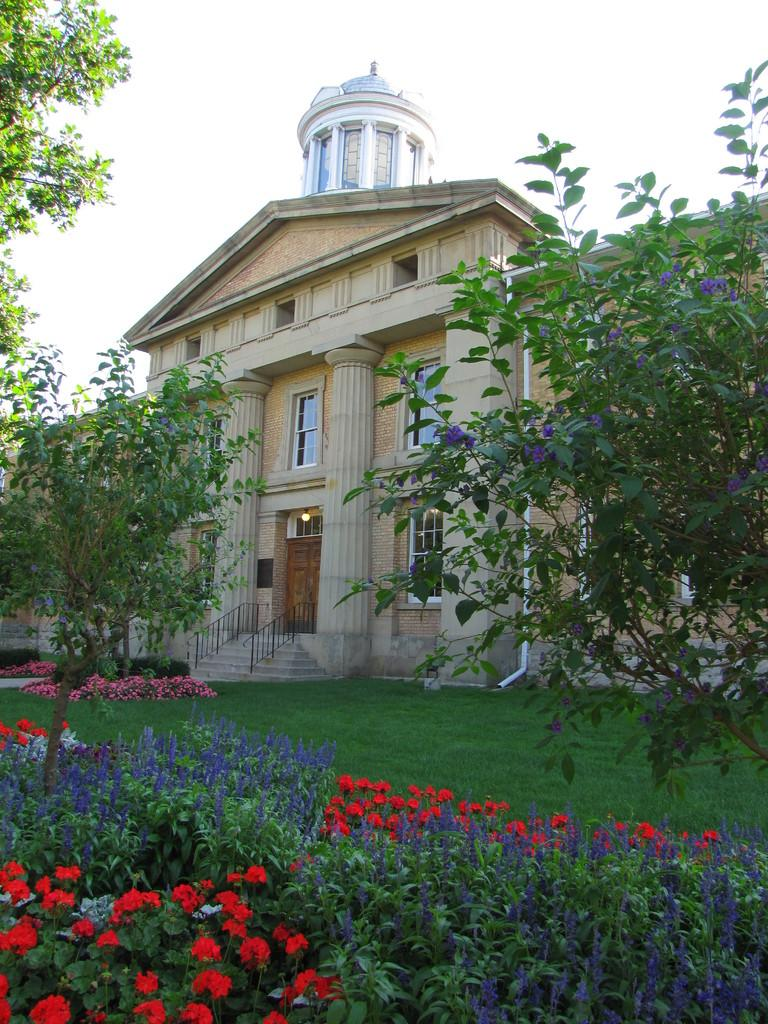What type of vegetation can be seen in the image? There are flowers, plants, grass, and trees in the image. What type of structure is present in the image? There is a building in the image. What architectural features can be seen on the building? There are pillars in the image. What can be seen through the windows in the image? The sky is visible in the image. What type of can is visible in the image? There is no can present in the image. Is there a collar visible on any of the plants in the image? There are no collars on the plants in the image, as plants do not wear collars. 